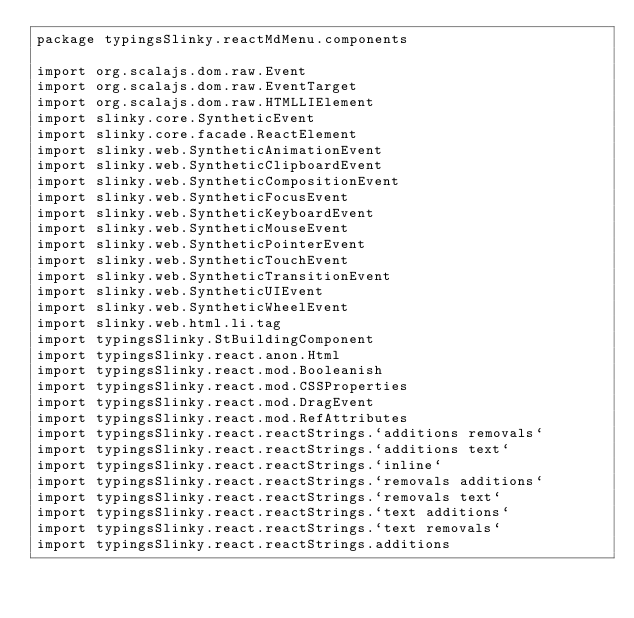Convert code to text. <code><loc_0><loc_0><loc_500><loc_500><_Scala_>package typingsSlinky.reactMdMenu.components

import org.scalajs.dom.raw.Event
import org.scalajs.dom.raw.EventTarget
import org.scalajs.dom.raw.HTMLLIElement
import slinky.core.SyntheticEvent
import slinky.core.facade.ReactElement
import slinky.web.SyntheticAnimationEvent
import slinky.web.SyntheticClipboardEvent
import slinky.web.SyntheticCompositionEvent
import slinky.web.SyntheticFocusEvent
import slinky.web.SyntheticKeyboardEvent
import slinky.web.SyntheticMouseEvent
import slinky.web.SyntheticPointerEvent
import slinky.web.SyntheticTouchEvent
import slinky.web.SyntheticTransitionEvent
import slinky.web.SyntheticUIEvent
import slinky.web.SyntheticWheelEvent
import slinky.web.html.li.tag
import typingsSlinky.StBuildingComponent
import typingsSlinky.react.anon.Html
import typingsSlinky.react.mod.Booleanish
import typingsSlinky.react.mod.CSSProperties
import typingsSlinky.react.mod.DragEvent
import typingsSlinky.react.mod.RefAttributes
import typingsSlinky.react.reactStrings.`additions removals`
import typingsSlinky.react.reactStrings.`additions text`
import typingsSlinky.react.reactStrings.`inline`
import typingsSlinky.react.reactStrings.`removals additions`
import typingsSlinky.react.reactStrings.`removals text`
import typingsSlinky.react.reactStrings.`text additions`
import typingsSlinky.react.reactStrings.`text removals`
import typingsSlinky.react.reactStrings.additions</code> 